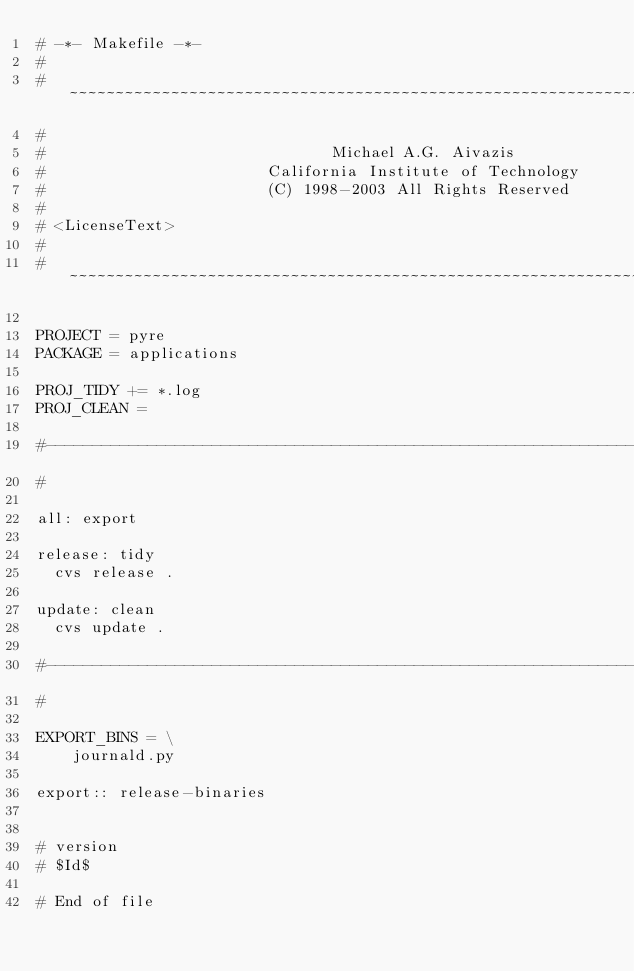Convert code to text. <code><loc_0><loc_0><loc_500><loc_500><_ObjectiveC_># -*- Makefile -*-
#
# ~~~~~~~~~~~~~~~~~~~~~~~~~~~~~~~~~~~~~~~~~~~~~~~~~~~~~~~~~~~~~~~~~~~~~~~~~~~~~~~~
#
#                               Michael A.G. Aivazis
#                        California Institute of Technology
#                        (C) 1998-2003 All Rights Reserved
#
# <LicenseText>
#
# ~~~~~~~~~~~~~~~~~~~~~~~~~~~~~~~~~~~~~~~~~~~~~~~~~~~~~~~~~~~~~~~~~~~~~~~~~~~~~~~~

PROJECT = pyre
PACKAGE = applications

PROJ_TIDY += *.log
PROJ_CLEAN =

#--------------------------------------------------------------------------
#

all: export

release: tidy
	cvs release .

update: clean
	cvs update .

#--------------------------------------------------------------------------
#

EXPORT_BINS = \
    journald.py

export:: release-binaries


# version
# $Id$

# End of file
</code> 